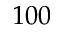Convert formula to latex. <formula><loc_0><loc_0><loc_500><loc_500>1 0 0</formula> 